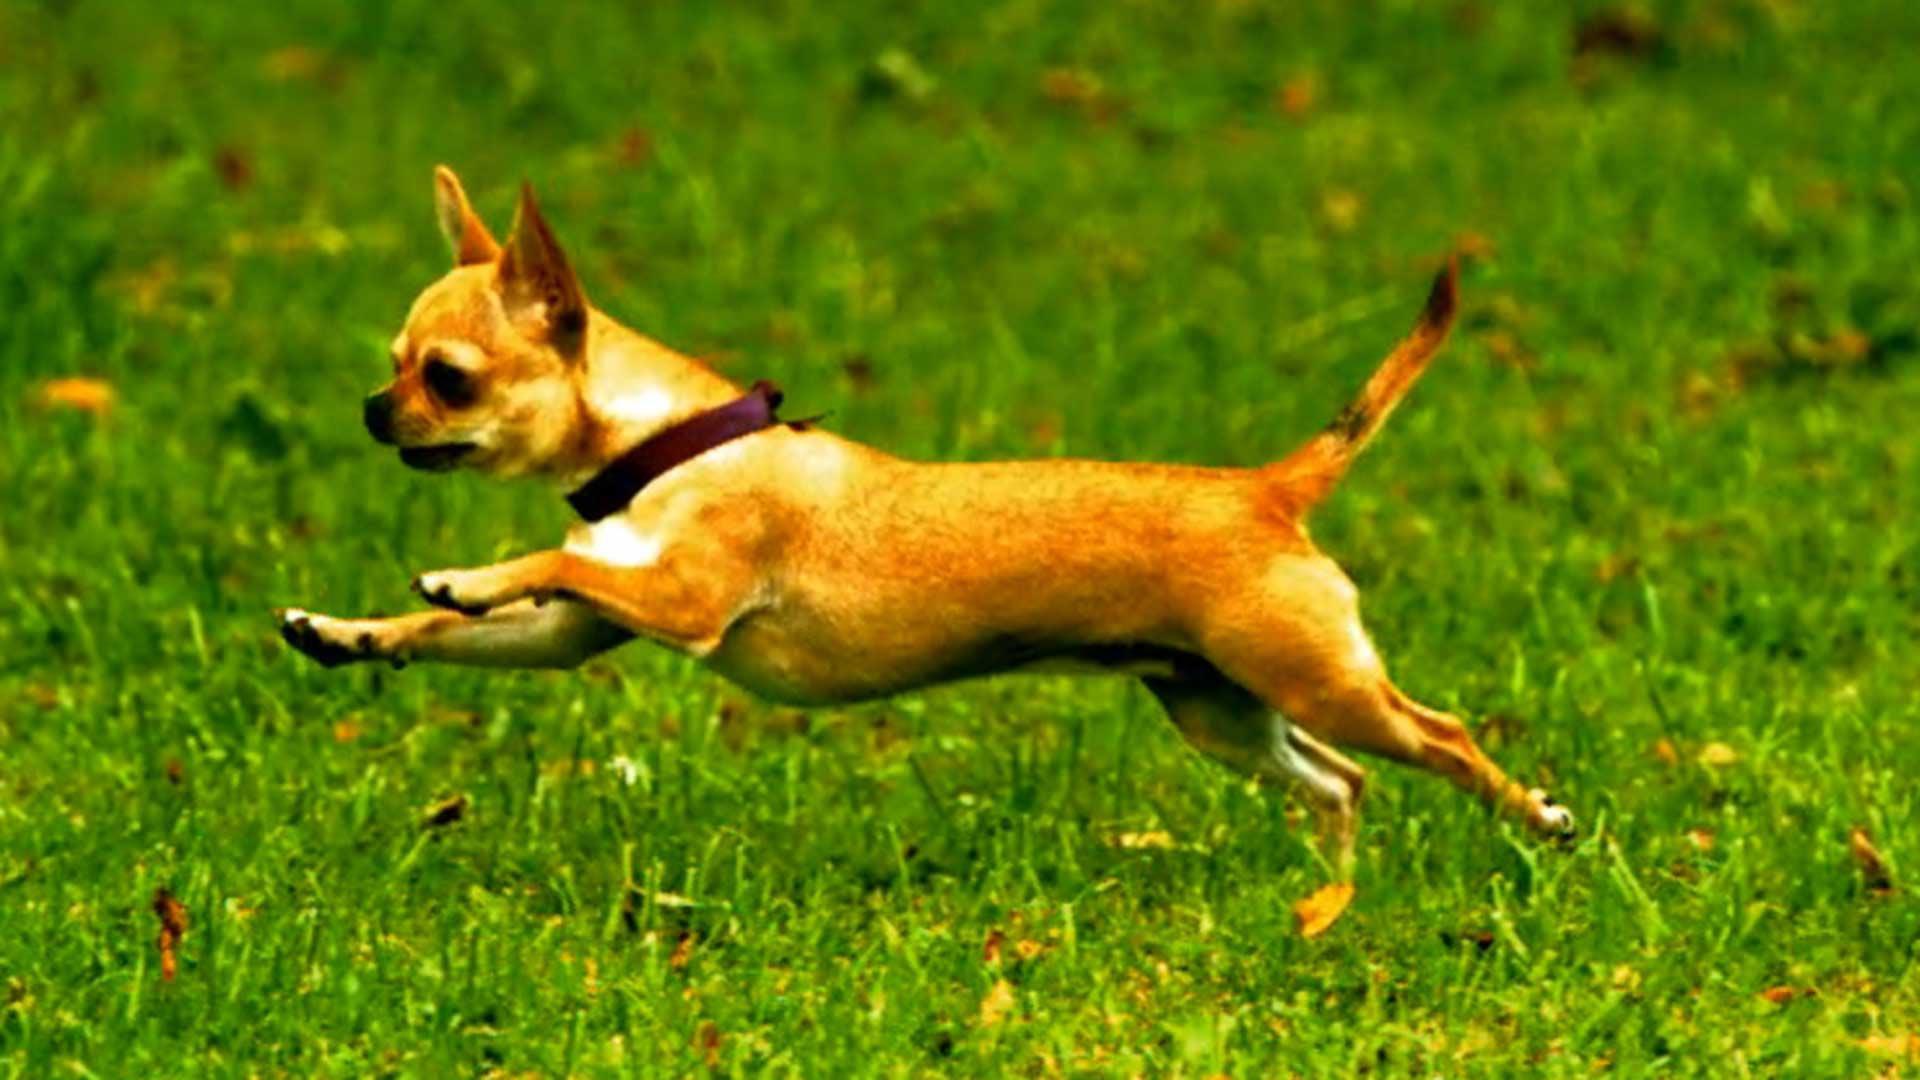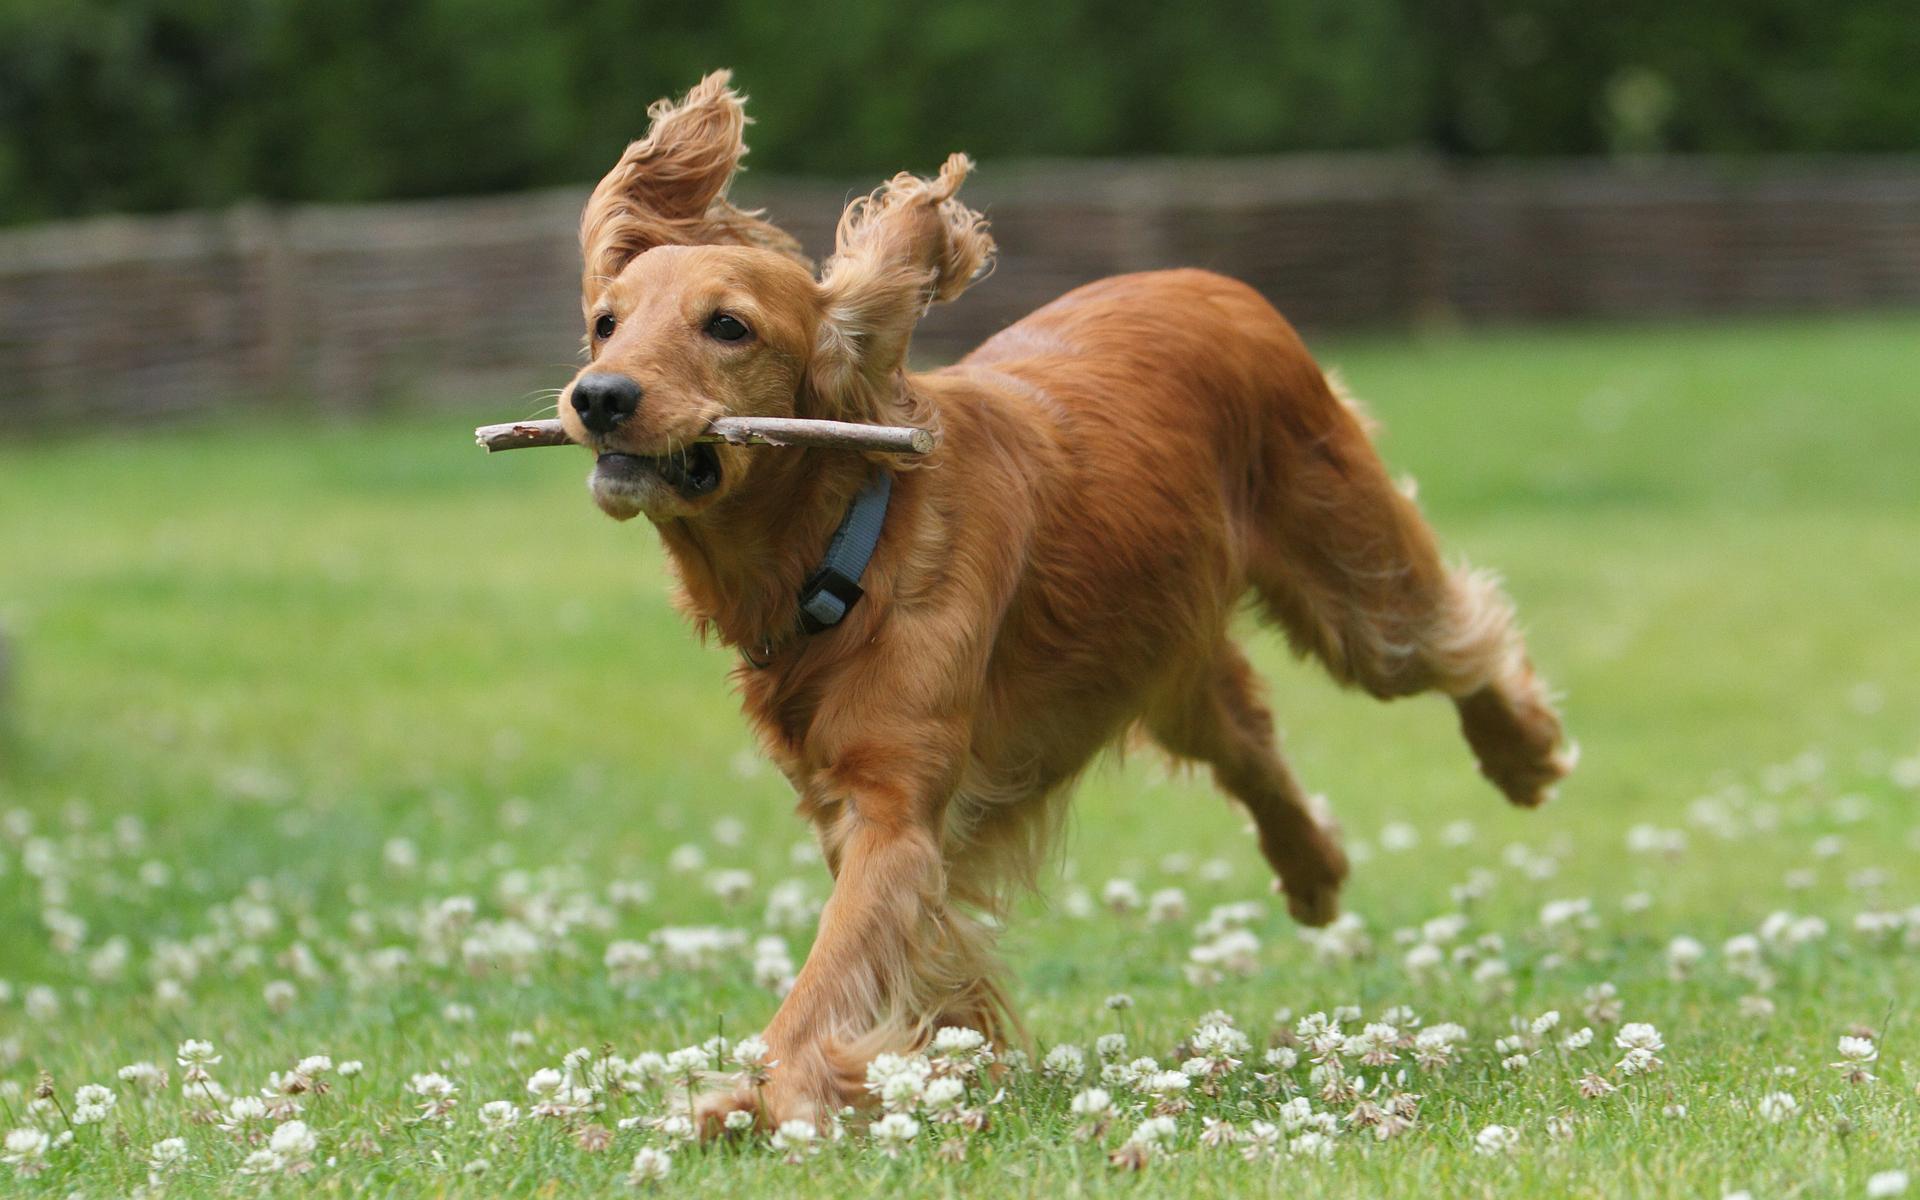The first image is the image on the left, the second image is the image on the right. Assess this claim about the two images: "All dogs in the images are running across the grass.". Correct or not? Answer yes or no. Yes. The first image is the image on the left, the second image is the image on the right. Examine the images to the left and right. Is the description "there is a mostly black dog leaping through the air in the image on the left" accurate? Answer yes or no. No. 